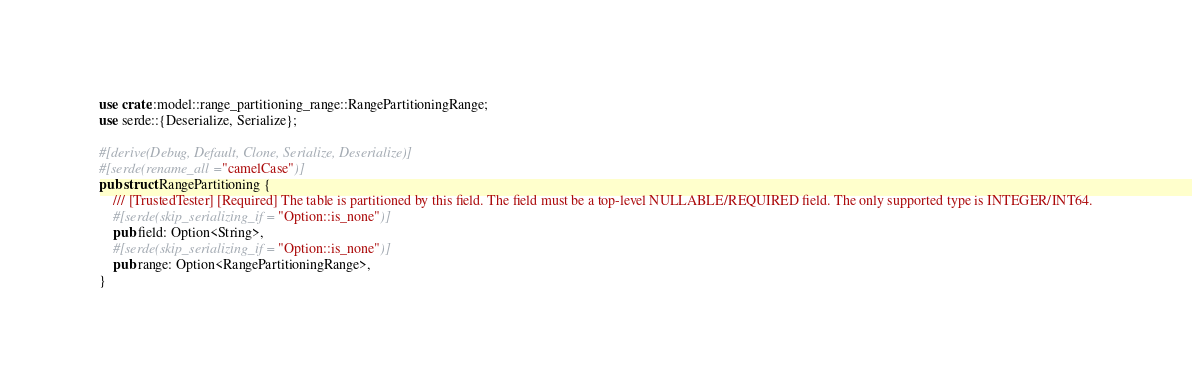Convert code to text. <code><loc_0><loc_0><loc_500><loc_500><_Rust_>use crate::model::range_partitioning_range::RangePartitioningRange;
use serde::{Deserialize, Serialize};

#[derive(Debug, Default, Clone, Serialize, Deserialize)]
#[serde(rename_all = "camelCase")]
pub struct RangePartitioning {
    /// [TrustedTester] [Required] The table is partitioned by this field. The field must be a top-level NULLABLE/REQUIRED field. The only supported type is INTEGER/INT64.
    #[serde(skip_serializing_if = "Option::is_none")]
    pub field: Option<String>,
    #[serde(skip_serializing_if = "Option::is_none")]
    pub range: Option<RangePartitioningRange>,
}
</code> 